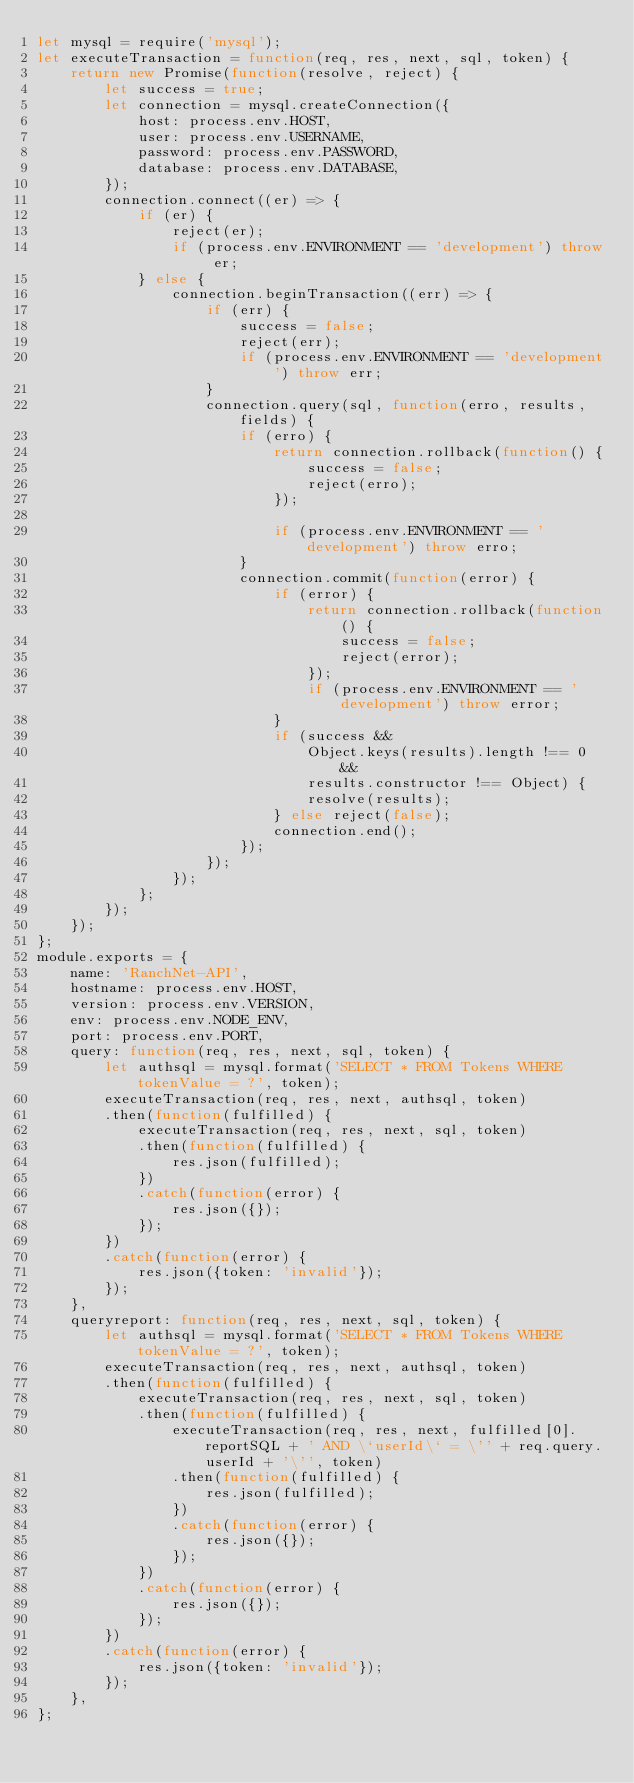Convert code to text. <code><loc_0><loc_0><loc_500><loc_500><_JavaScript_>let mysql = require('mysql');
let executeTransaction = function(req, res, next, sql, token) {
    return new Promise(function(resolve, reject) {
        let success = true;
        let connection = mysql.createConnection({
            host: process.env.HOST,
            user: process.env.USERNAME,
            password: process.env.PASSWORD,
            database: process.env.DATABASE,
        });
        connection.connect((er) => {
            if (er) {
                reject(er);
                if (process.env.ENVIRONMENT == 'development') throw er;
            } else {
                connection.beginTransaction((err) => {
                    if (err) {
                        success = false;
                        reject(err);
                        if (process.env.ENVIRONMENT == 'development') throw err;
                    }
                    connection.query(sql, function(erro, results, fields) {
                        if (erro) {
                            return connection.rollback(function() {
                                success = false;
                                reject(erro);
                            });

                            if (process.env.ENVIRONMENT == 'development') throw erro;
                        }
                        connection.commit(function(error) {
                            if (error) {
                                return connection.rollback(function() {
                                    success = false;
                                    reject(error);
                                });
                                if (process.env.ENVIRONMENT == 'development') throw error;
                            }
                            if (success &&
                                Object.keys(results).length !== 0 &&
                                results.constructor !== Object) {
                                resolve(results);
                            } else reject(false);
                            connection.end();
                        });
                    });
                });
            };
        });
    });
};
module.exports = {
    name: 'RanchNet-API',
    hostname: process.env.HOST,
    version: process.env.VERSION,
    env: process.env.NODE_ENV,
    port: process.env.PORT,
    query: function(req, res, next, sql, token) {
        let authsql = mysql.format('SELECT * FROM Tokens WHERE tokenValue = ?', token);
        executeTransaction(req, res, next, authsql, token)
        .then(function(fulfilled) {
            executeTransaction(req, res, next, sql, token)
            .then(function(fulfilled) {
                res.json(fulfilled);
            })
            .catch(function(error) {
                res.json({});
            });
        })
        .catch(function(error) {
            res.json({token: 'invalid'});
        });
    },
    queryreport: function(req, res, next, sql, token) {
        let authsql = mysql.format('SELECT * FROM Tokens WHERE tokenValue = ?', token);
        executeTransaction(req, res, next, authsql, token)
        .then(function(fulfilled) {
            executeTransaction(req, res, next, sql, token)
            .then(function(fulfilled) {
                executeTransaction(req, res, next, fulfilled[0].reportSQL + ' AND \`userId\` = \'' + req.query.userId + '\'', token)
                .then(function(fulfilled) {
                    res.json(fulfilled);
                })
                .catch(function(error) {
                    res.json({});
                });
            })
            .catch(function(error) {
                res.json({});
            });
        })
        .catch(function(error) {
            res.json({token: 'invalid'});
        });
    },
};
</code> 